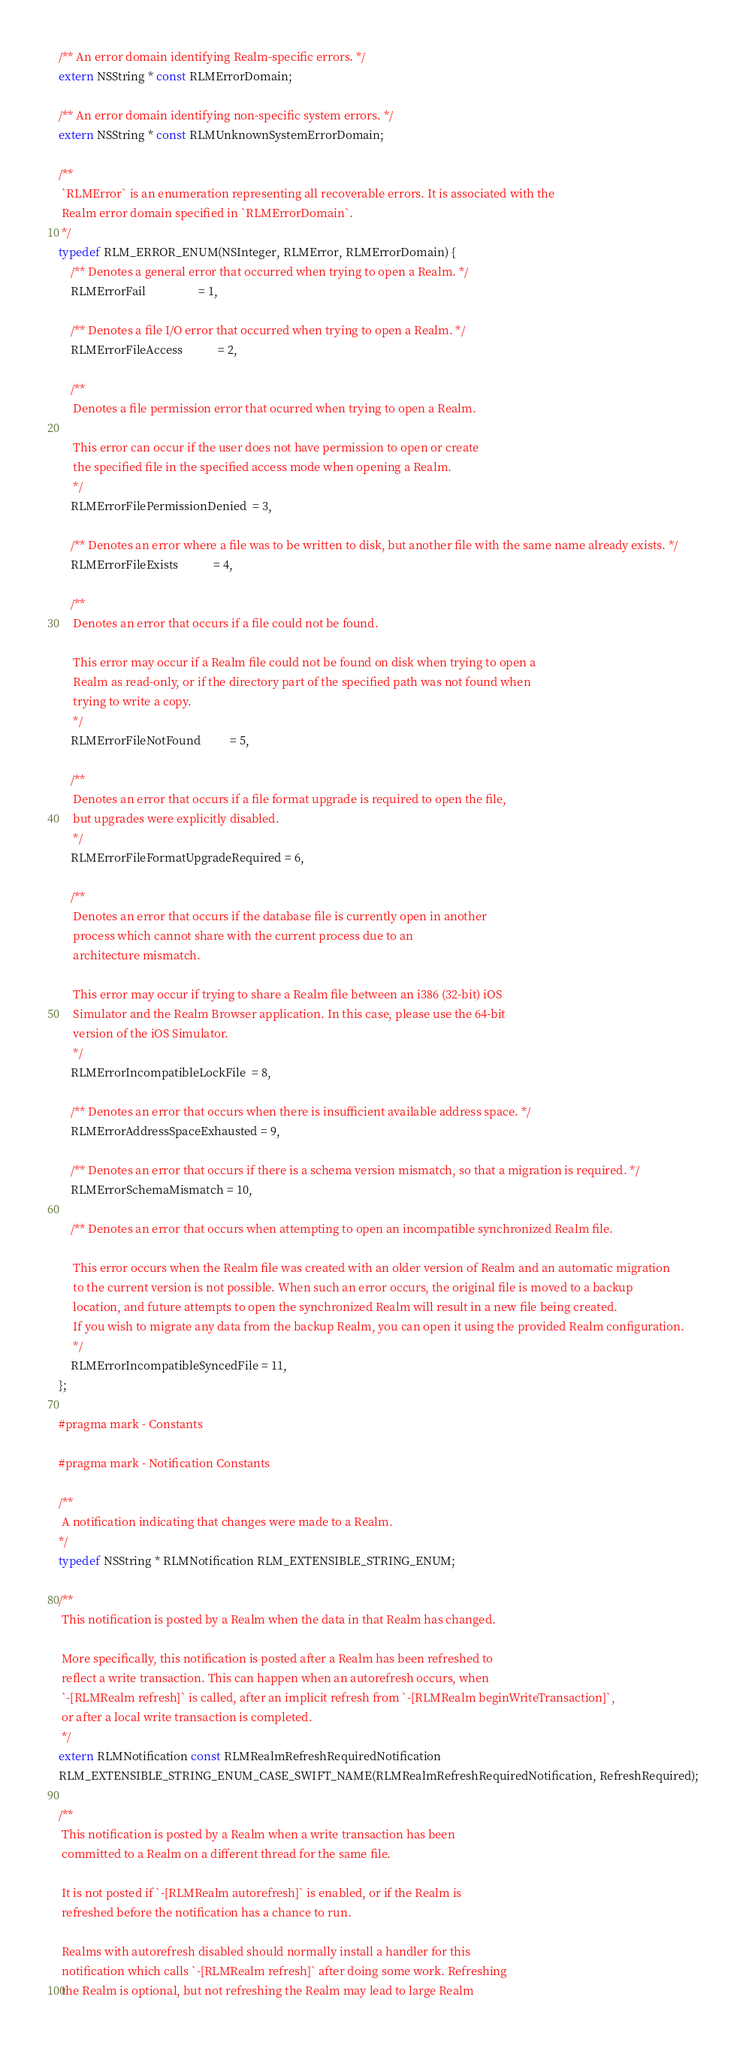<code> <loc_0><loc_0><loc_500><loc_500><_C_>/** An error domain identifying Realm-specific errors. */
extern NSString * const RLMErrorDomain;

/** An error domain identifying non-specific system errors. */
extern NSString * const RLMUnknownSystemErrorDomain;

/**
 `RLMError` is an enumeration representing all recoverable errors. It is associated with the
 Realm error domain specified in `RLMErrorDomain`.
 */
typedef RLM_ERROR_ENUM(NSInteger, RLMError, RLMErrorDomain) {
    /** Denotes a general error that occurred when trying to open a Realm. */
    RLMErrorFail                  = 1,

    /** Denotes a file I/O error that occurred when trying to open a Realm. */
    RLMErrorFileAccess            = 2,

    /**
     Denotes a file permission error that ocurred when trying to open a Realm.

     This error can occur if the user does not have permission to open or create
     the specified file in the specified access mode when opening a Realm.
     */
    RLMErrorFilePermissionDenied  = 3,

    /** Denotes an error where a file was to be written to disk, but another file with the same name already exists. */
    RLMErrorFileExists            = 4,

    /**
     Denotes an error that occurs if a file could not be found.

     This error may occur if a Realm file could not be found on disk when trying to open a
     Realm as read-only, or if the directory part of the specified path was not found when
     trying to write a copy.
     */
    RLMErrorFileNotFound          = 5,

    /**
     Denotes an error that occurs if a file format upgrade is required to open the file,
     but upgrades were explicitly disabled.
     */
    RLMErrorFileFormatUpgradeRequired = 6,

    /**
     Denotes an error that occurs if the database file is currently open in another
     process which cannot share with the current process due to an
     architecture mismatch.

     This error may occur if trying to share a Realm file between an i386 (32-bit) iOS
     Simulator and the Realm Browser application. In this case, please use the 64-bit
     version of the iOS Simulator.
     */
    RLMErrorIncompatibleLockFile  = 8,

    /** Denotes an error that occurs when there is insufficient available address space. */
    RLMErrorAddressSpaceExhausted = 9,

    /** Denotes an error that occurs if there is a schema version mismatch, so that a migration is required. */
    RLMErrorSchemaMismatch = 10,

    /** Denotes an error that occurs when attempting to open an incompatible synchronized Realm file.

     This error occurs when the Realm file was created with an older version of Realm and an automatic migration
     to the current version is not possible. When such an error occurs, the original file is moved to a backup
     location, and future attempts to open the synchronized Realm will result in a new file being created.
     If you wish to migrate any data from the backup Realm, you can open it using the provided Realm configuration.
     */
    RLMErrorIncompatibleSyncedFile = 11,
};

#pragma mark - Constants

#pragma mark - Notification Constants

/**
 A notification indicating that changes were made to a Realm.
*/
typedef NSString * RLMNotification RLM_EXTENSIBLE_STRING_ENUM;

/**
 This notification is posted by a Realm when the data in that Realm has changed.

 More specifically, this notification is posted after a Realm has been refreshed to
 reflect a write transaction. This can happen when an autorefresh occurs, when
 `-[RLMRealm refresh]` is called, after an implicit refresh from `-[RLMRealm beginWriteTransaction]`,
 or after a local write transaction is completed.
 */
extern RLMNotification const RLMRealmRefreshRequiredNotification
RLM_EXTENSIBLE_STRING_ENUM_CASE_SWIFT_NAME(RLMRealmRefreshRequiredNotification, RefreshRequired);

/**
 This notification is posted by a Realm when a write transaction has been
 committed to a Realm on a different thread for the same file.

 It is not posted if `-[RLMRealm autorefresh]` is enabled, or if the Realm is
 refreshed before the notification has a chance to run.

 Realms with autorefresh disabled should normally install a handler for this
 notification which calls `-[RLMRealm refresh]` after doing some work. Refreshing
 the Realm is optional, but not refreshing the Realm may lead to large Realm</code> 